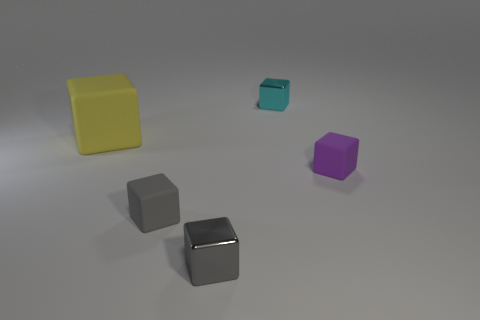Is the tiny block that is right of the small cyan cube made of the same material as the cyan cube?
Provide a succinct answer. No. Is there any other thing of the same color as the big block?
Your answer should be very brief. No. Is the shape of the small cyan metallic thing behind the purple rubber cube the same as the small rubber thing that is left of the purple matte object?
Ensure brevity in your answer.  Yes. How many things are either gray matte objects or shiny cubes that are on the left side of the cyan cube?
Give a very brief answer. 2. What number of other objects are the same size as the yellow rubber cube?
Give a very brief answer. 0. Does the block that is behind the large yellow block have the same material as the tiny gray object that is to the right of the tiny gray matte cube?
Your answer should be compact. Yes. How many gray rubber blocks are left of the big rubber object?
Your answer should be compact. 0. How many blue objects are either shiny cubes or shiny cylinders?
Your answer should be compact. 0. There is a purple block that is the same size as the cyan block; what is it made of?
Give a very brief answer. Rubber. There is a tiny object that is to the right of the gray matte block and in front of the purple rubber cube; what shape is it?
Your answer should be very brief. Cube. 